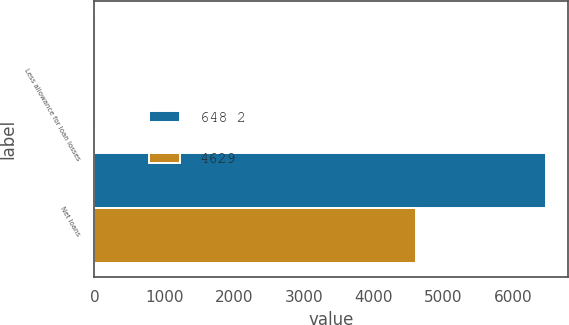Convert chart. <chart><loc_0><loc_0><loc_500><loc_500><stacked_bar_chart><ecel><fcel>Less allowance for loan losses<fcel>Net loans<nl><fcel>648 2<fcel>18<fcel>6464<nl><fcel>4629<fcel>18<fcel>4611<nl></chart> 